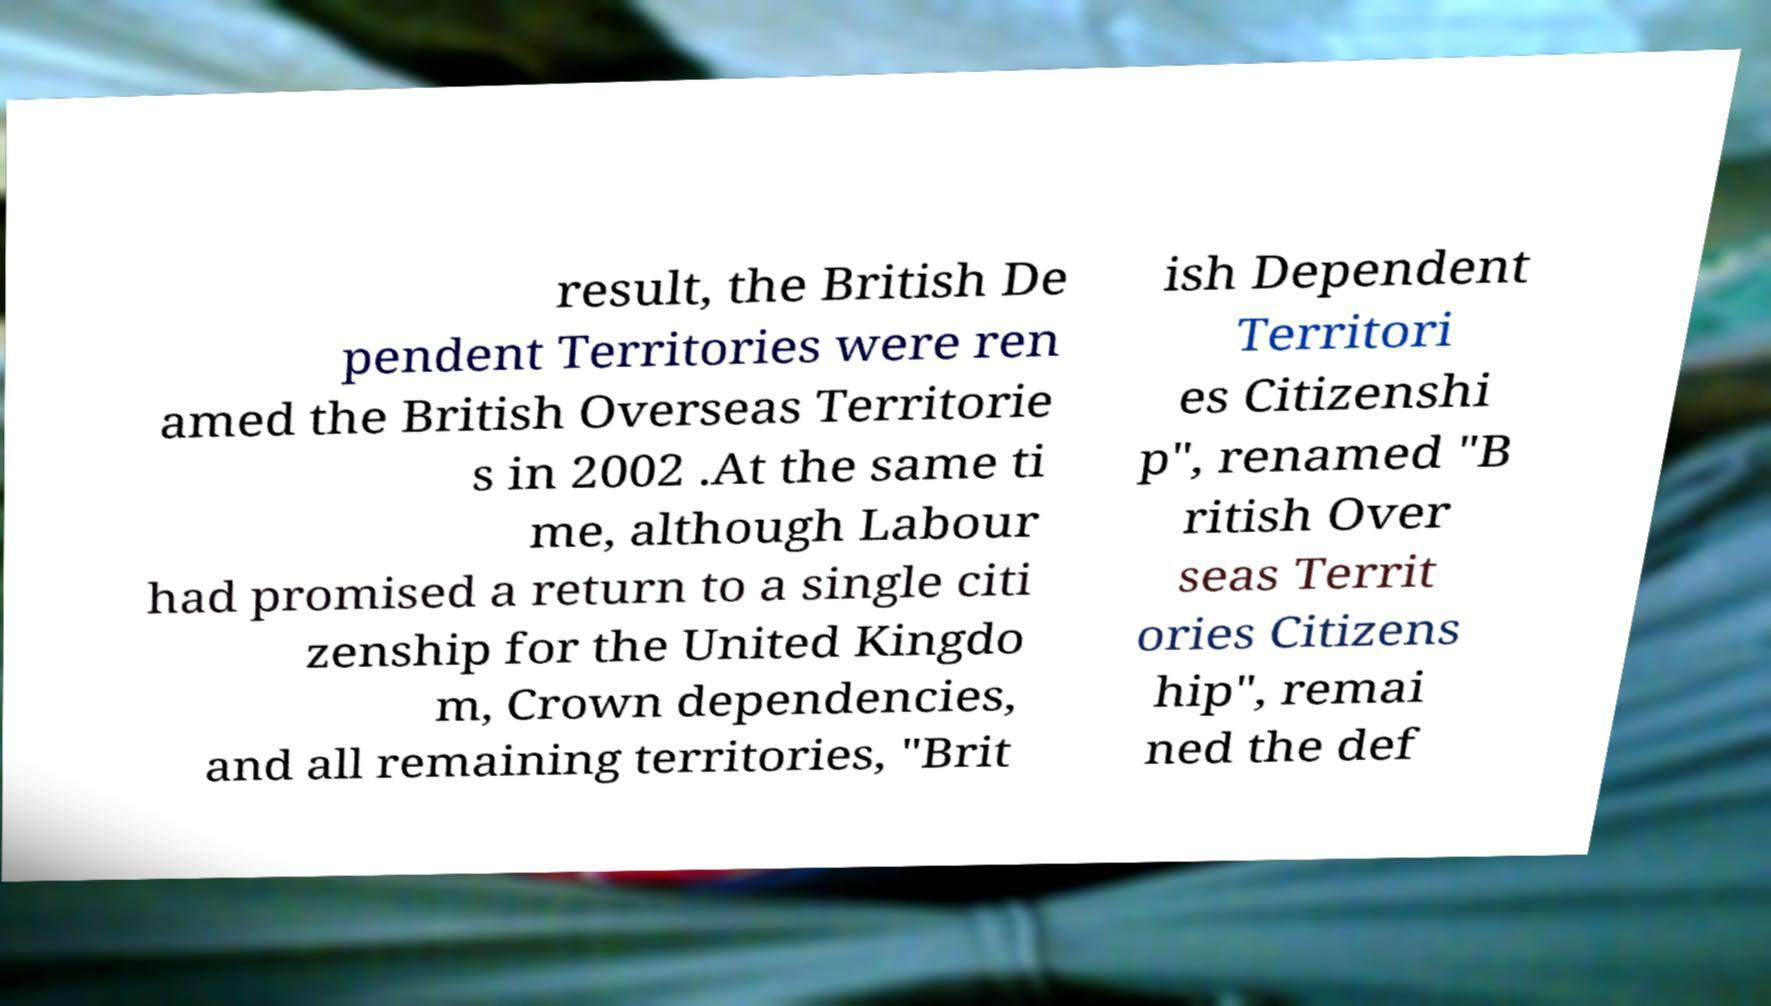Can you accurately transcribe the text from the provided image for me? result, the British De pendent Territories were ren amed the British Overseas Territorie s in 2002 .At the same ti me, although Labour had promised a return to a single citi zenship for the United Kingdo m, Crown dependencies, and all remaining territories, "Brit ish Dependent Territori es Citizenshi p", renamed "B ritish Over seas Territ ories Citizens hip", remai ned the def 